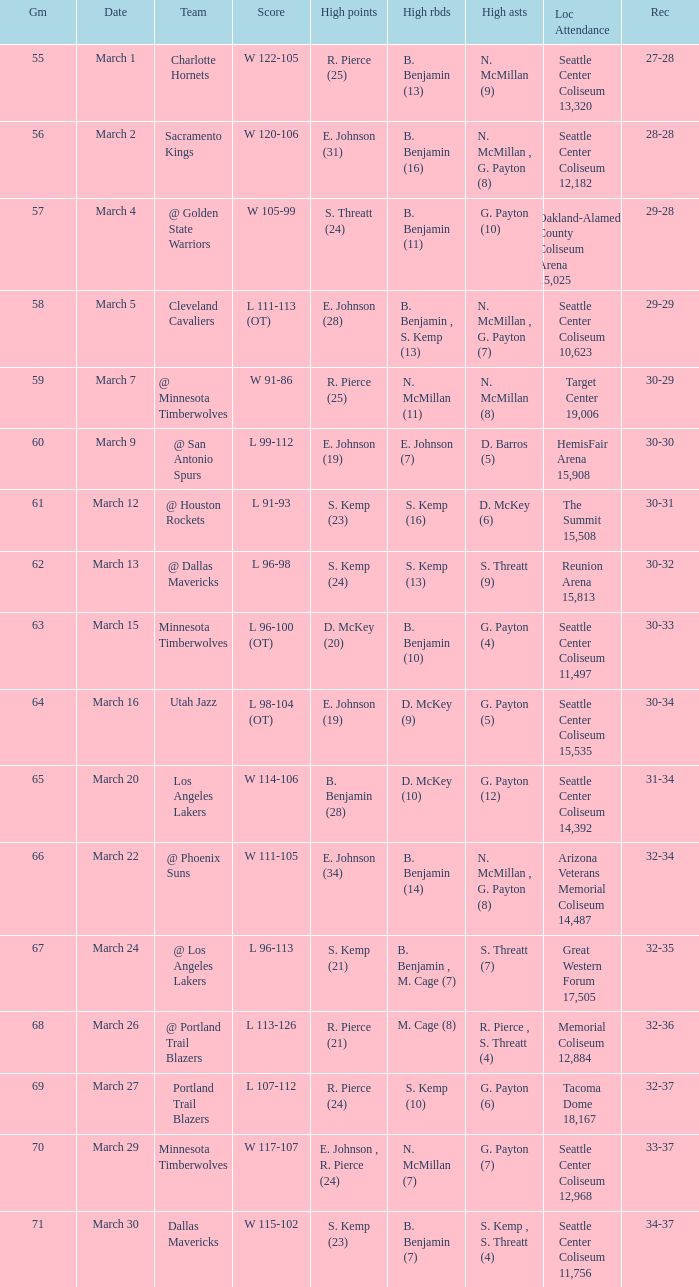Which Game has High assists of s. threatt (9)? 62.0. 